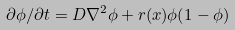<formula> <loc_0><loc_0><loc_500><loc_500>\partial \phi / \partial t = D \nabla ^ { 2 } \phi + r ( x ) \phi ( 1 - \phi )</formula> 